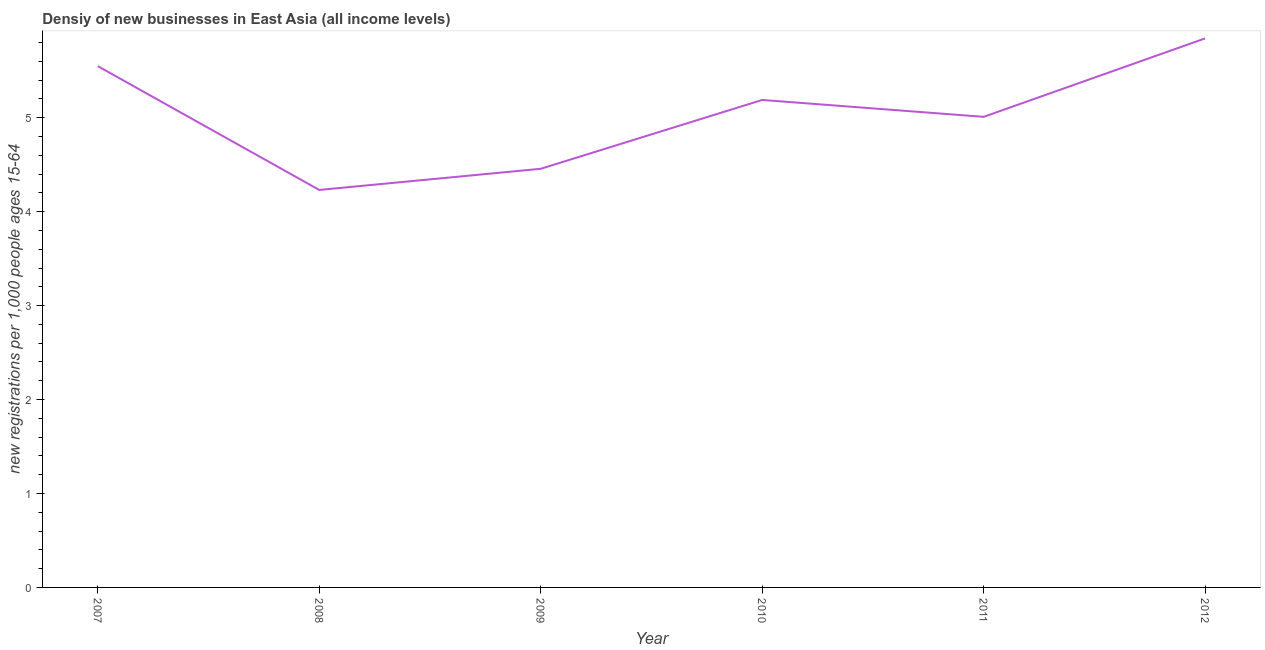What is the density of new business in 2008?
Provide a short and direct response. 4.23. Across all years, what is the maximum density of new business?
Provide a succinct answer. 5.84. Across all years, what is the minimum density of new business?
Give a very brief answer. 4.23. What is the sum of the density of new business?
Your answer should be compact. 30.28. What is the difference between the density of new business in 2009 and 2011?
Your answer should be very brief. -0.55. What is the average density of new business per year?
Offer a very short reply. 5.05. What is the median density of new business?
Provide a succinct answer. 5.1. In how many years, is the density of new business greater than 2.8 ?
Your answer should be very brief. 6. What is the ratio of the density of new business in 2008 to that in 2011?
Your response must be concise. 0.84. What is the difference between the highest and the second highest density of new business?
Offer a terse response. 0.3. Is the sum of the density of new business in 2008 and 2009 greater than the maximum density of new business across all years?
Offer a terse response. Yes. What is the difference between the highest and the lowest density of new business?
Keep it short and to the point. 1.61. In how many years, is the density of new business greater than the average density of new business taken over all years?
Keep it short and to the point. 3. Does the density of new business monotonically increase over the years?
Provide a short and direct response. No. How many lines are there?
Provide a succinct answer. 1. Are the values on the major ticks of Y-axis written in scientific E-notation?
Keep it short and to the point. No. What is the title of the graph?
Your answer should be compact. Densiy of new businesses in East Asia (all income levels). What is the label or title of the Y-axis?
Offer a terse response. New registrations per 1,0 people ages 15-64. What is the new registrations per 1,000 people ages 15-64 in 2007?
Your answer should be compact. 5.55. What is the new registrations per 1,000 people ages 15-64 of 2008?
Provide a short and direct response. 4.23. What is the new registrations per 1,000 people ages 15-64 in 2009?
Your answer should be very brief. 4.46. What is the new registrations per 1,000 people ages 15-64 in 2010?
Make the answer very short. 5.19. What is the new registrations per 1,000 people ages 15-64 of 2011?
Your answer should be compact. 5.01. What is the new registrations per 1,000 people ages 15-64 of 2012?
Give a very brief answer. 5.84. What is the difference between the new registrations per 1,000 people ages 15-64 in 2007 and 2008?
Your answer should be very brief. 1.32. What is the difference between the new registrations per 1,000 people ages 15-64 in 2007 and 2009?
Keep it short and to the point. 1.09. What is the difference between the new registrations per 1,000 people ages 15-64 in 2007 and 2010?
Ensure brevity in your answer.  0.36. What is the difference between the new registrations per 1,000 people ages 15-64 in 2007 and 2011?
Your answer should be compact. 0.54. What is the difference between the new registrations per 1,000 people ages 15-64 in 2007 and 2012?
Your answer should be compact. -0.3. What is the difference between the new registrations per 1,000 people ages 15-64 in 2008 and 2009?
Keep it short and to the point. -0.23. What is the difference between the new registrations per 1,000 people ages 15-64 in 2008 and 2010?
Provide a short and direct response. -0.96. What is the difference between the new registrations per 1,000 people ages 15-64 in 2008 and 2011?
Give a very brief answer. -0.78. What is the difference between the new registrations per 1,000 people ages 15-64 in 2008 and 2012?
Your answer should be very brief. -1.61. What is the difference between the new registrations per 1,000 people ages 15-64 in 2009 and 2010?
Provide a short and direct response. -0.73. What is the difference between the new registrations per 1,000 people ages 15-64 in 2009 and 2011?
Your answer should be compact. -0.55. What is the difference between the new registrations per 1,000 people ages 15-64 in 2009 and 2012?
Your answer should be very brief. -1.39. What is the difference between the new registrations per 1,000 people ages 15-64 in 2010 and 2011?
Ensure brevity in your answer.  0.18. What is the difference between the new registrations per 1,000 people ages 15-64 in 2010 and 2012?
Your response must be concise. -0.66. What is the difference between the new registrations per 1,000 people ages 15-64 in 2011 and 2012?
Your answer should be compact. -0.83. What is the ratio of the new registrations per 1,000 people ages 15-64 in 2007 to that in 2008?
Keep it short and to the point. 1.31. What is the ratio of the new registrations per 1,000 people ages 15-64 in 2007 to that in 2009?
Make the answer very short. 1.25. What is the ratio of the new registrations per 1,000 people ages 15-64 in 2007 to that in 2010?
Provide a succinct answer. 1.07. What is the ratio of the new registrations per 1,000 people ages 15-64 in 2007 to that in 2011?
Offer a very short reply. 1.11. What is the ratio of the new registrations per 1,000 people ages 15-64 in 2007 to that in 2012?
Your answer should be very brief. 0.95. What is the ratio of the new registrations per 1,000 people ages 15-64 in 2008 to that in 2009?
Offer a terse response. 0.95. What is the ratio of the new registrations per 1,000 people ages 15-64 in 2008 to that in 2010?
Your response must be concise. 0.81. What is the ratio of the new registrations per 1,000 people ages 15-64 in 2008 to that in 2011?
Provide a short and direct response. 0.84. What is the ratio of the new registrations per 1,000 people ages 15-64 in 2008 to that in 2012?
Your answer should be compact. 0.72. What is the ratio of the new registrations per 1,000 people ages 15-64 in 2009 to that in 2010?
Your answer should be very brief. 0.86. What is the ratio of the new registrations per 1,000 people ages 15-64 in 2009 to that in 2011?
Your response must be concise. 0.89. What is the ratio of the new registrations per 1,000 people ages 15-64 in 2009 to that in 2012?
Your answer should be very brief. 0.76. What is the ratio of the new registrations per 1,000 people ages 15-64 in 2010 to that in 2011?
Your response must be concise. 1.04. What is the ratio of the new registrations per 1,000 people ages 15-64 in 2010 to that in 2012?
Give a very brief answer. 0.89. What is the ratio of the new registrations per 1,000 people ages 15-64 in 2011 to that in 2012?
Give a very brief answer. 0.86. 